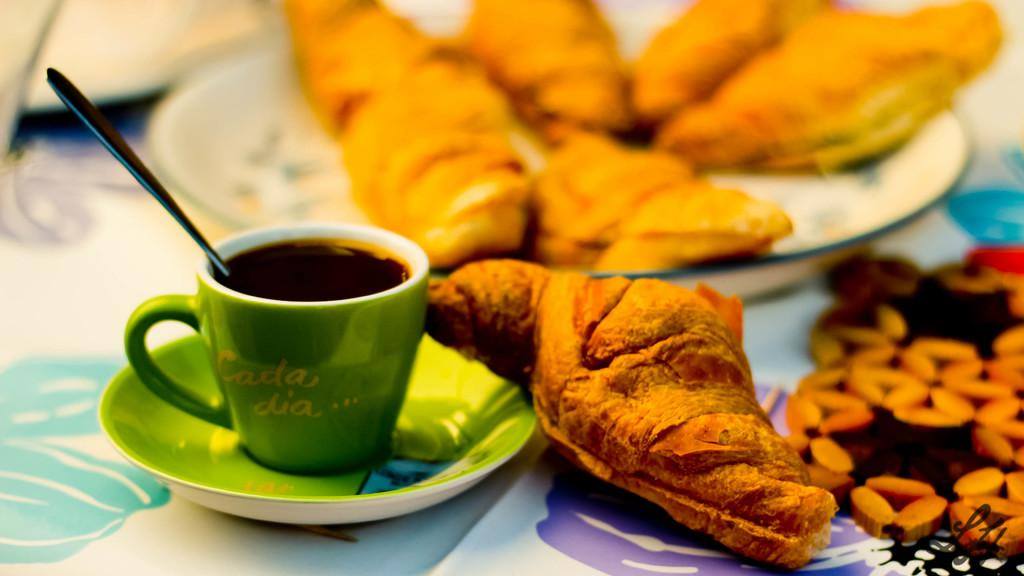What is the main piece of furniture in the image? There is a table in the image. How is the table decorated or covered? The table is covered with a cloth. What type of dishware can be seen on the table? A tea cup, a saucer, and a spoon are placed on the table. What is on the plate that is placed on the table? A plate with food items is placed on the table. Where is the vase located in the image? There is no vase present in the image. What type of bone can be seen on the table in the image? There is no bone present on the table in the image. 